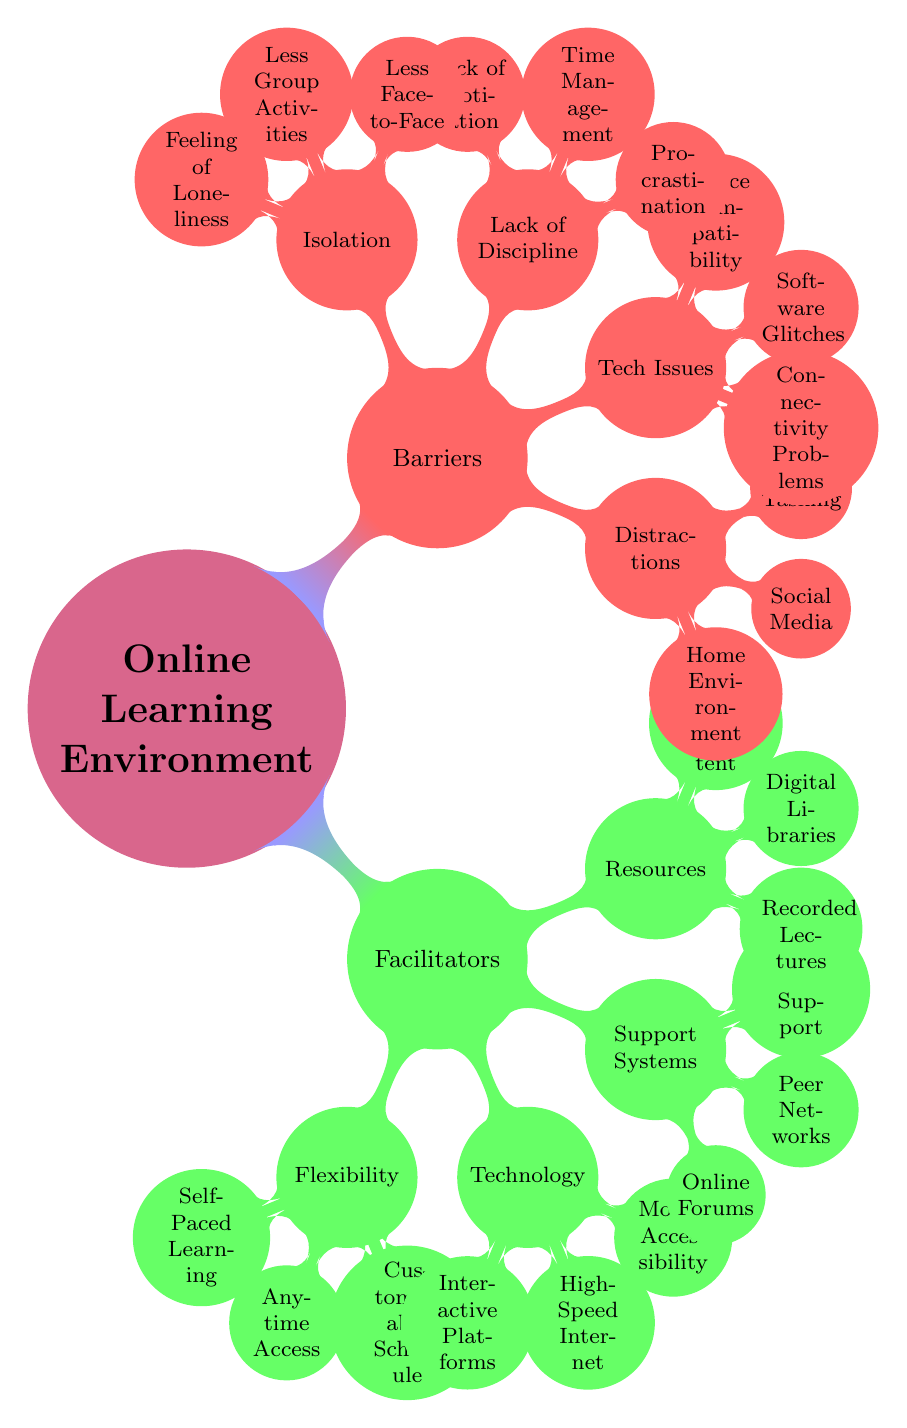What is the main focus of the diagram? The main focus of the diagram is labeled as "Online Learning Environment," which is the central node from which facilitators and barriers branch out.
Answer: Online Learning Environment How many facilitators are identified in the diagram? There are four facilitators listed under the "Facilitators" node: Flexibility, Technology, Support Systems, and Resources.
Answer: 4 What is one of the barriers listed under "Distractions"? One of the barriers is "Home Environment," which is specifically mentioned as a distraction.
Answer: Home Environment Which facilitator includes "Anytime Access"? "Anytime Access" is part of the "Flexibility" facilitator, indicating it supports flexible learning.
Answer: Flexibility What combination of factors could lead to student isolation? Student isolation can result from a lack of face-to-face interaction and less group activities, leading to feelings of loneliness.
Answer: Less Face-to-Face, Less Group Activities, Feeling of Loneliness What technology-related issues are mentioned as barriers? The barriers related to technology issues include connectivity problems, software glitches, and device compatibility, which can hinder online learning.
Answer: Connectivity Problems, Software Glitches, Device Compatibility How does "Procrastination" affect student engagement? "Procrastination" is identified under "Lack of Discipline," suggesting it negatively impacts student engagement by delaying study efforts.
Answer: Lack of Discipline What do "Recorded Lectures" fall under? "Recorded Lectures" is categorized under the "Resources" facilitator, indicating it is a vital resource that supports student success in online learning.
Answer: Resources Can you name a type of support system available for online learners? "Online Forums" is one type of support system available for online learners, enhancing student engagement and interaction.
Answer: Online Forums 